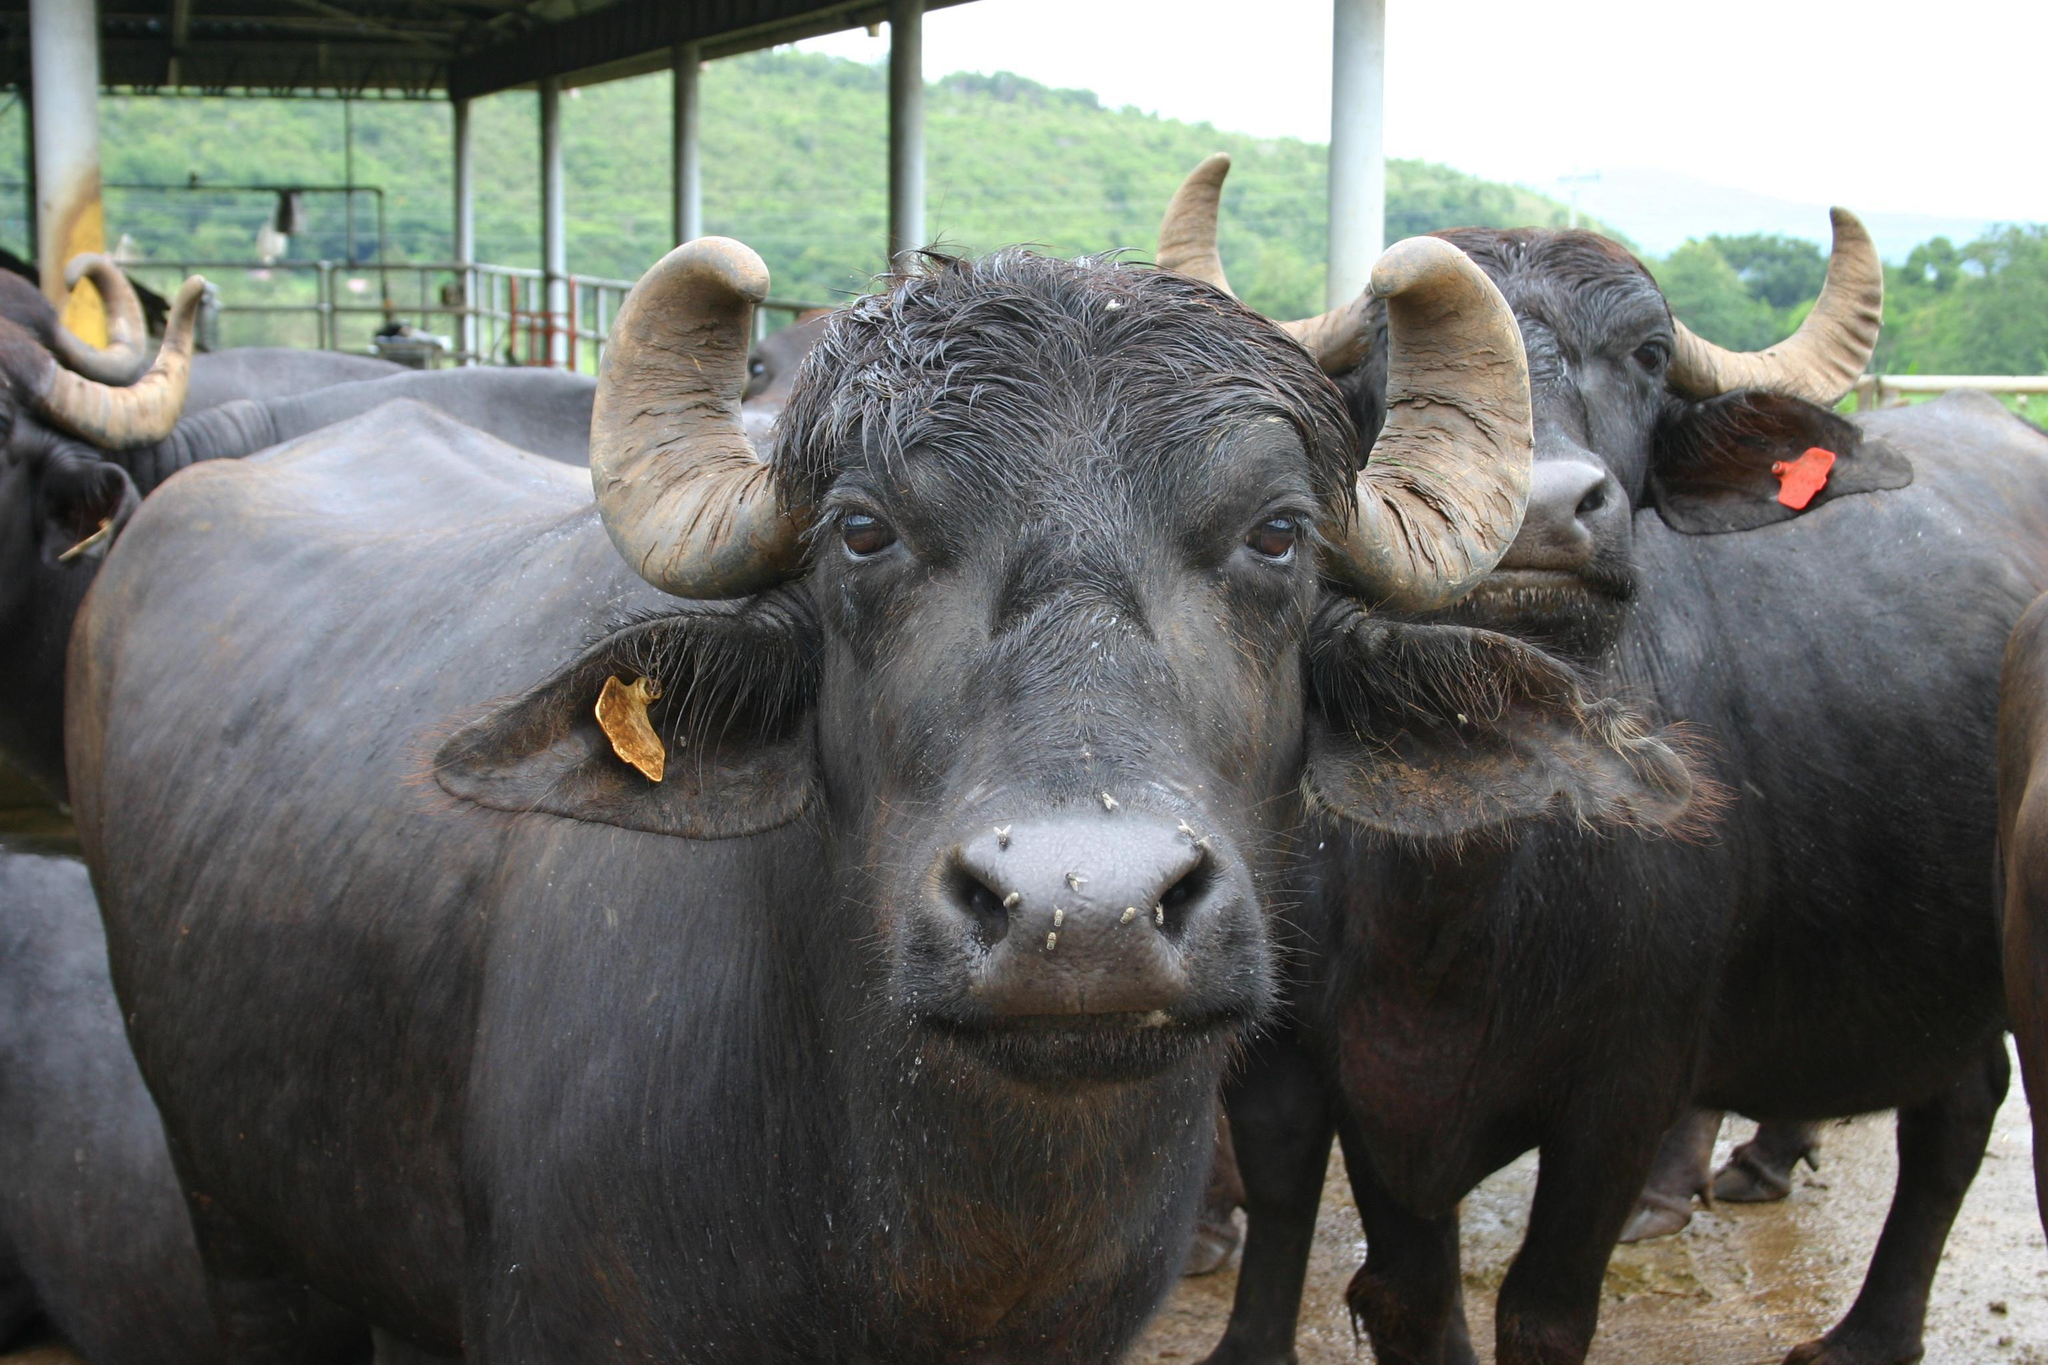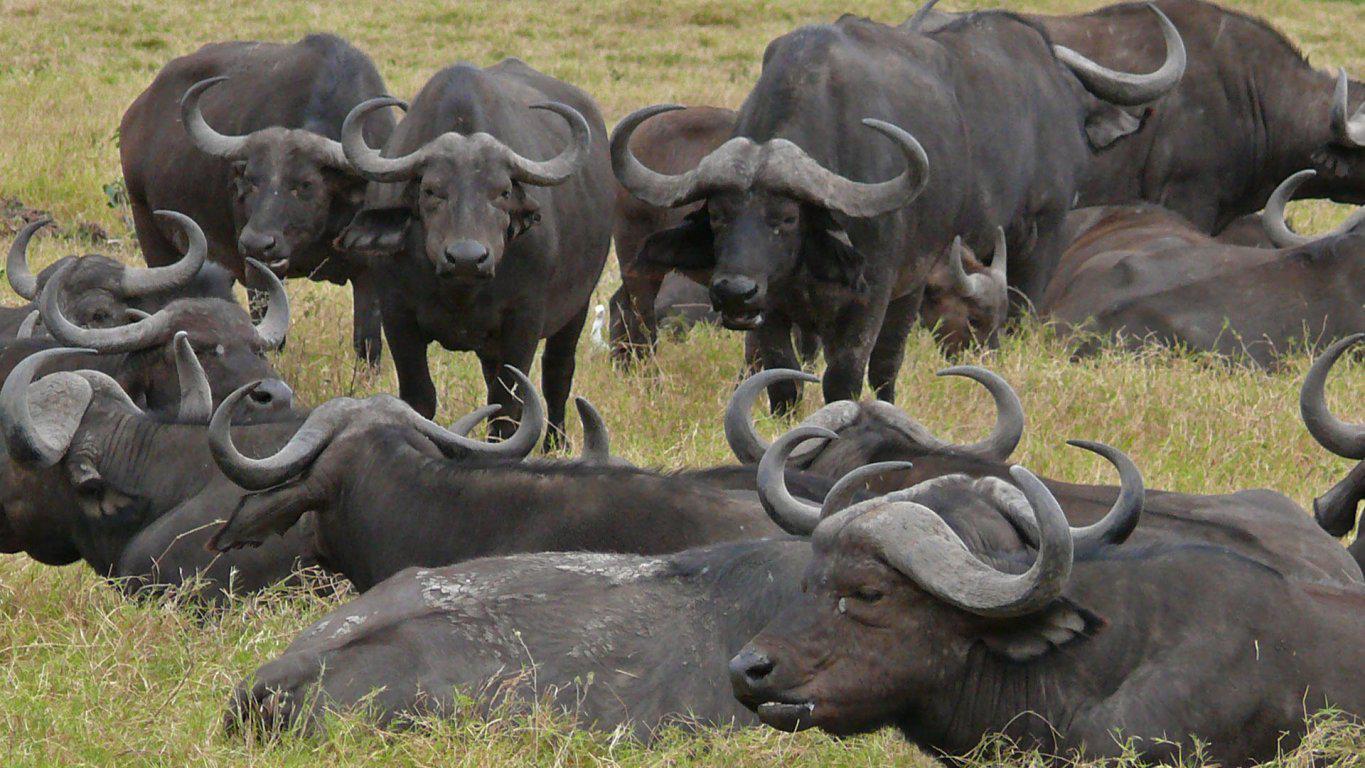The first image is the image on the left, the second image is the image on the right. For the images displayed, is the sentence "There are fewer than 5 water buffalos" factually correct? Answer yes or no. No. The first image is the image on the left, the second image is the image on the right. Analyze the images presented: Is the assertion "There are at most 5 water buffalo." valid? Answer yes or no. No. 